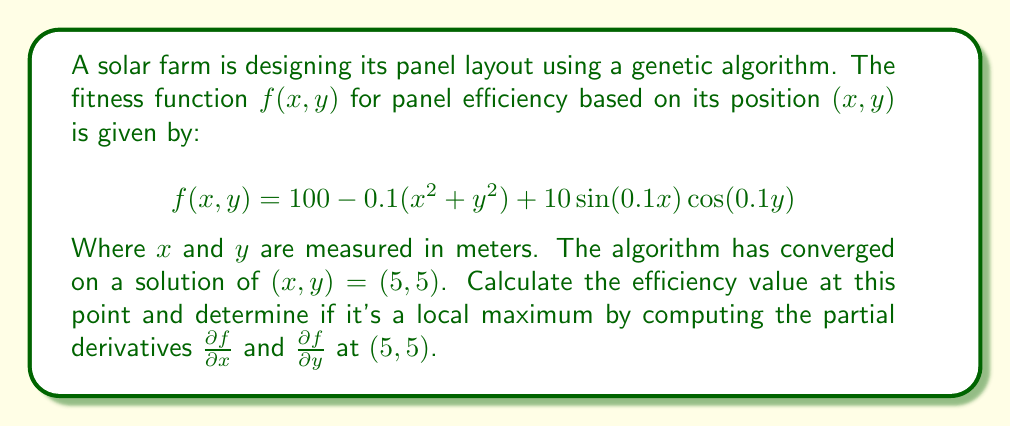Can you answer this question? To solve this problem, we'll follow these steps:

1. Calculate the efficiency value at $(5, 5)$:
   Substitute $x = 5$ and $y = 5$ into the fitness function:
   
   $$f(5, 5) = 100 - 0.1(5^2 + 5^2) + 10\sin(0.1 \cdot 5)\cos(0.1 \cdot 5)$$
   $$= 100 - 0.1(25 + 25) + 10\sin(0.5)\cos(0.5)$$
   $$= 100 - 5 + 10 \cdot 0.479425539 \cdot 0.877582562$$
   $$= 95 + 4.207354924 = 99.20735492$$

2. Compute partial derivatives:
   
   $$\frac{\partial f}{\partial x} = -0.2x + \cos(0.1x)\cos(0.1y)$$
   $$\frac{\partial f}{\partial y} = -0.2y - \sin(0.1x)\sin(0.1y)$$

3. Evaluate partial derivatives at $(5, 5)$:
   
   $$\frac{\partial f}{\partial x}(5, 5) = -0.2(5) + \cos(0.5)\cos(0.5) = -1 + 0.877582562 \cdot 0.877582562 = -0.22999997$$
   
   $$\frac{\partial f}{\partial y}(5, 5) = -0.2(5) - \sin(0.5)\sin(0.5) = -1 - 0.479425539 \cdot 0.479425539 = -1.22999997$$

4. Interpret results:
   For a local maximum, both partial derivatives should equal zero. Since neither partial derivative is zero, $(5, 5)$ is not a local maximum. The negative values indicate that the efficiency can be improved by decreasing both $x$ and $y$.
Answer: The efficiency value at $(5, 5)$ is approximately 99.20735492. This point is not a local maximum, as $\frac{\partial f}{\partial x}(5, 5) \approx -0.22999997$ and $\frac{\partial f}{\partial y}(5, 5) \approx -1.22999997$, which are both non-zero. 